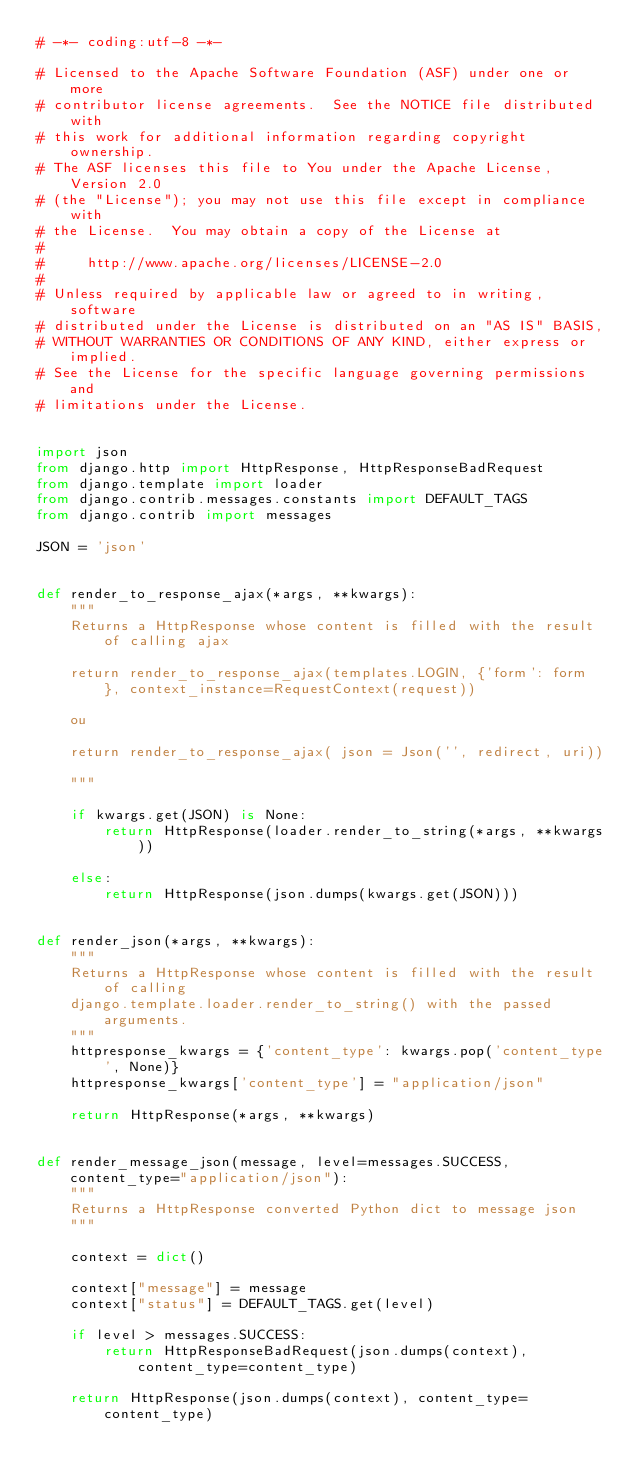Convert code to text. <code><loc_0><loc_0><loc_500><loc_500><_Python_># -*- coding:utf-8 -*-

# Licensed to the Apache Software Foundation (ASF) under one or more
# contributor license agreements.  See the NOTICE file distributed with
# this work for additional information regarding copyright ownership.
# The ASF licenses this file to You under the Apache License, Version 2.0
# (the "License"); you may not use this file except in compliance with
# the License.  You may obtain a copy of the License at
#
#     http://www.apache.org/licenses/LICENSE-2.0
#
# Unless required by applicable law or agreed to in writing, software
# distributed under the License is distributed on an "AS IS" BASIS,
# WITHOUT WARRANTIES OR CONDITIONS OF ANY KIND, either express or implied.
# See the License for the specific language governing permissions and
# limitations under the License.


import json
from django.http import HttpResponse, HttpResponseBadRequest
from django.template import loader
from django.contrib.messages.constants import DEFAULT_TAGS
from django.contrib import messages

JSON = 'json'


def render_to_response_ajax(*args, **kwargs):
    """
    Returns a HttpResponse whose content is filled with the result of calling ajax

    return render_to_response_ajax(templates.LOGIN, {'form': form }, context_instance=RequestContext(request))

    ou

    return render_to_response_ajax( json = Json('', redirect, uri))

    """

    if kwargs.get(JSON) is None:
        return HttpResponse(loader.render_to_string(*args, **kwargs))

    else:
        return HttpResponse(json.dumps(kwargs.get(JSON)))


def render_json(*args, **kwargs):
    """
    Returns a HttpResponse whose content is filled with the result of calling
    django.template.loader.render_to_string() with the passed arguments.
    """
    httpresponse_kwargs = {'content_type': kwargs.pop('content_type', None)}
    httpresponse_kwargs['content_type'] = "application/json"

    return HttpResponse(*args, **kwargs)


def render_message_json(message, level=messages.SUCCESS, content_type="application/json"):
    """
    Returns a HttpResponse converted Python dict to message json
    """

    context = dict()

    context["message"] = message
    context["status"] = DEFAULT_TAGS.get(level)

    if level > messages.SUCCESS:
        return HttpResponseBadRequest(json.dumps(context), content_type=content_type)

    return HttpResponse(json.dumps(context), content_type=content_type)
</code> 